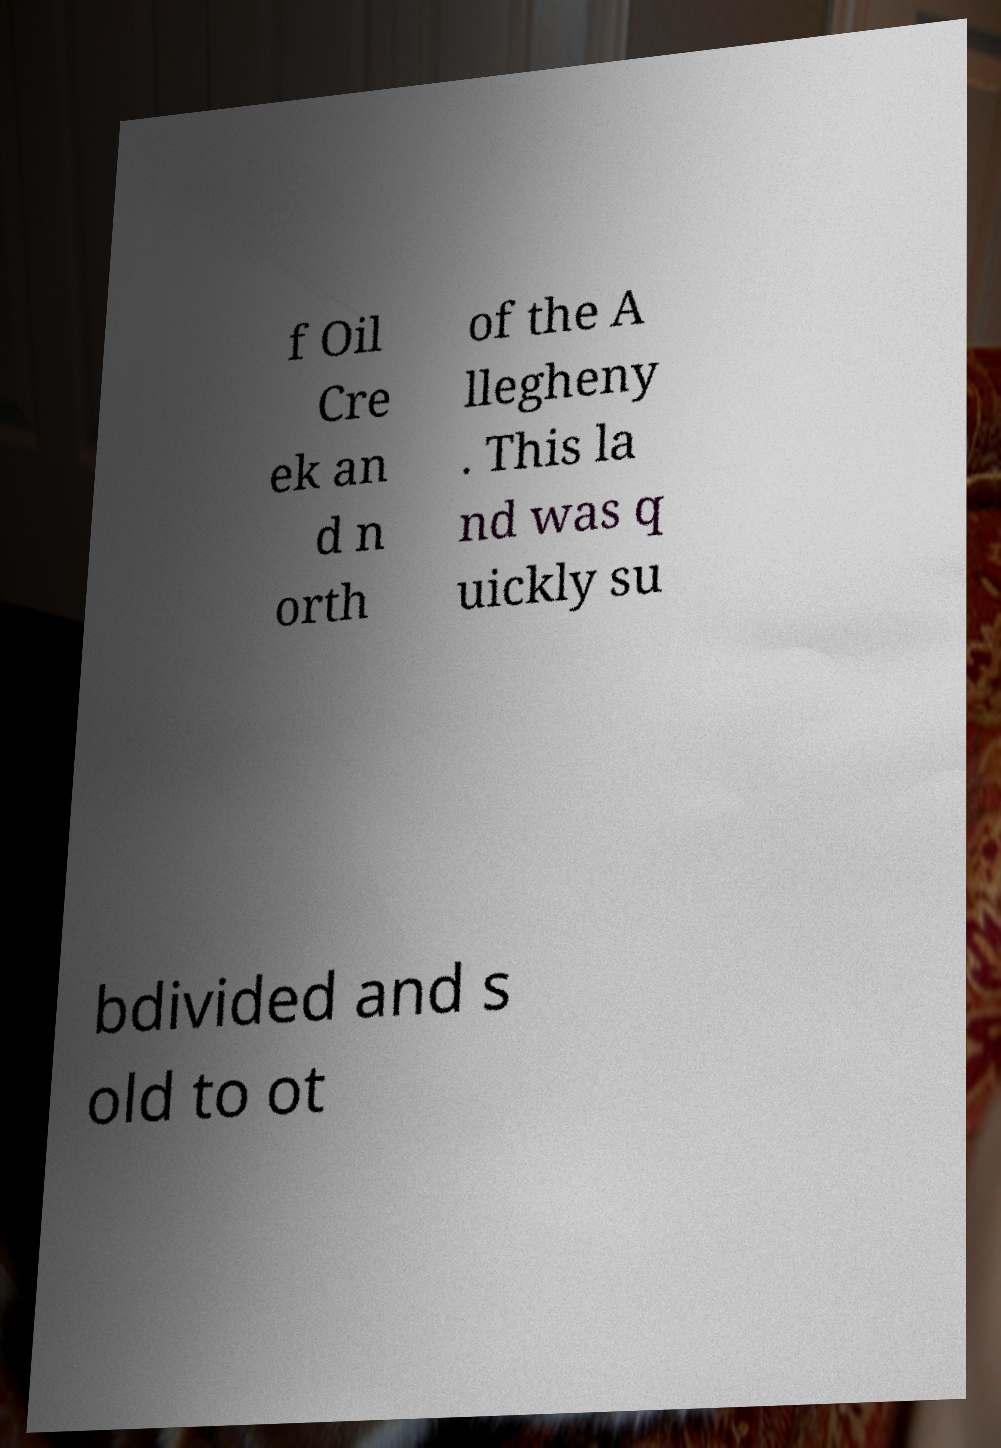Can you accurately transcribe the text from the provided image for me? f Oil Cre ek an d n orth of the A llegheny . This la nd was q uickly su bdivided and s old to ot 